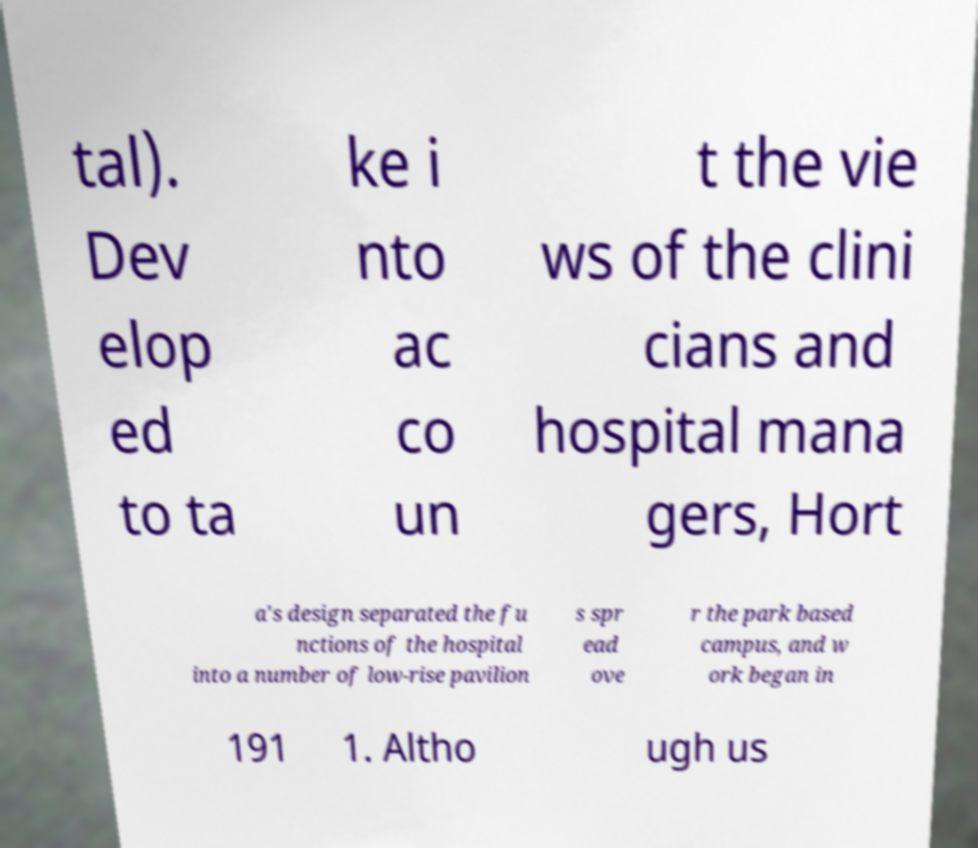There's text embedded in this image that I need extracted. Can you transcribe it verbatim? tal). Dev elop ed to ta ke i nto ac co un t the vie ws of the clini cians and hospital mana gers, Hort a's design separated the fu nctions of the hospital into a number of low-rise pavilion s spr ead ove r the park based campus, and w ork began in 191 1. Altho ugh us 